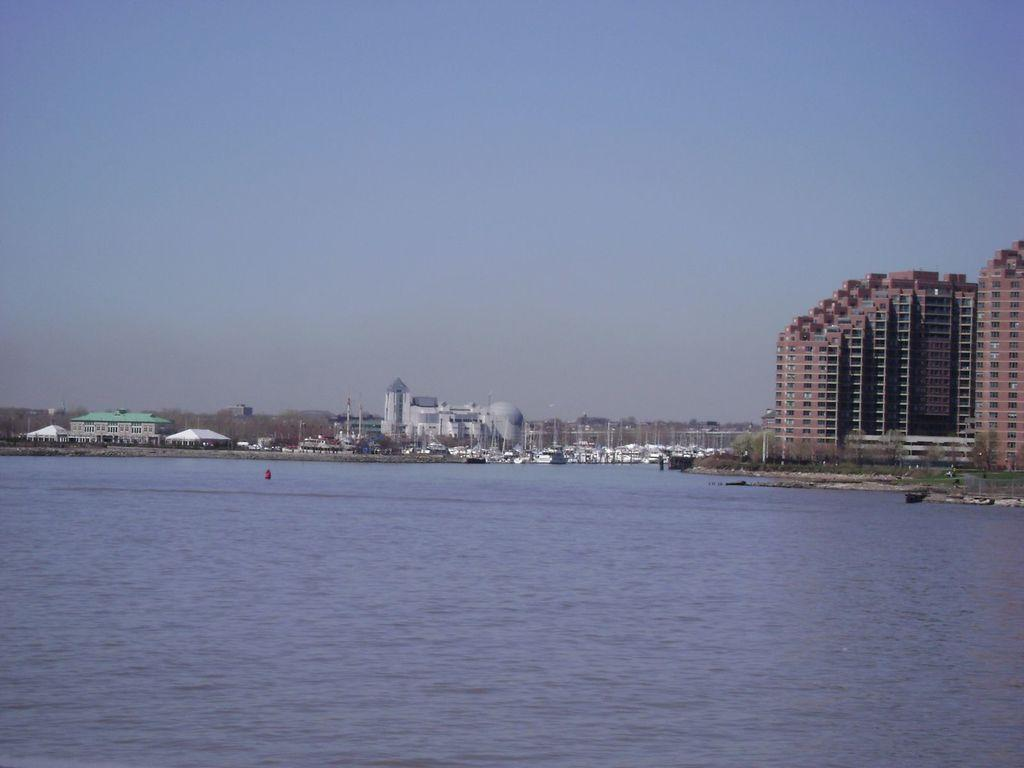What type of structures can be seen in the image? There are buildings in the image. What is located on the water in the image? There are boats on water in the image. What type of vegetation is present in the image? There are trees in the image. What can be seen in the background of the image? The sky is visible in the background of the image. Where can the wine be found in the image? There is no wine present in the image. How much money is visible in the image? There is no money visible in the image. 